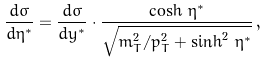Convert formula to latex. <formula><loc_0><loc_0><loc_500><loc_500>\frac { d \sigma } { d \eta ^ { * } } = \frac { d \sigma } { d y ^ { * } } \cdot \frac { \cosh \, \eta ^ { * } } { \sqrt { m _ { T } ^ { 2 } / p _ { T } ^ { 2 } + \sinh ^ { 2 } \, \eta ^ { * } } } \, ,</formula> 